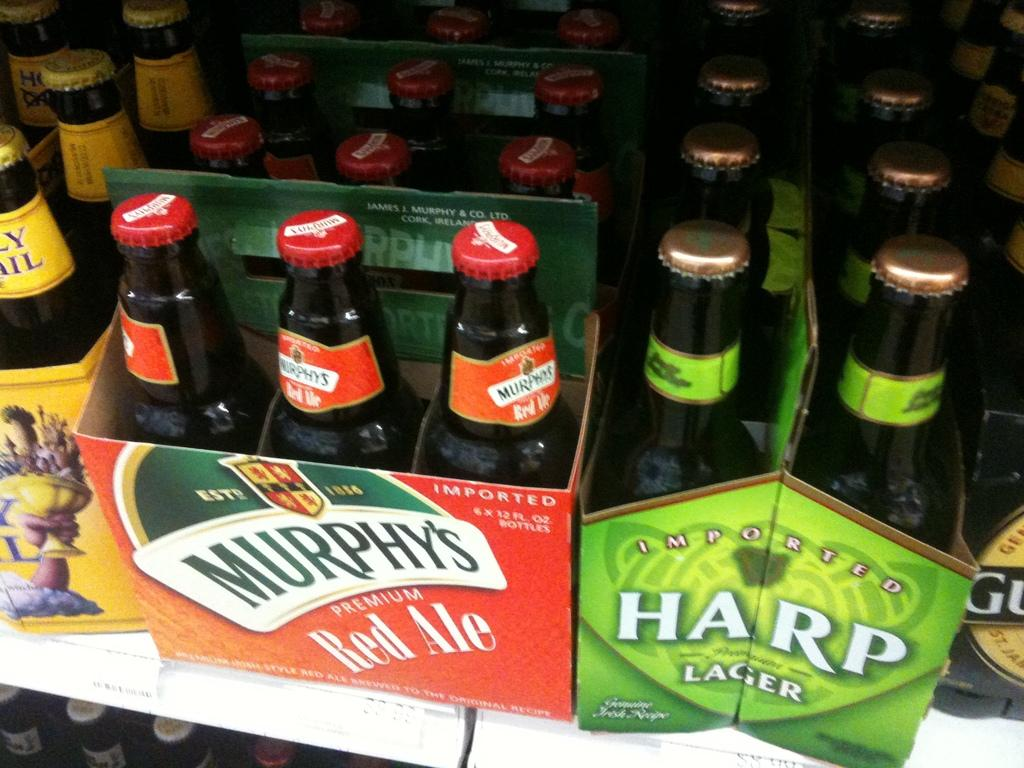<image>
Write a terse but informative summary of the picture. A six pack of Murphy's Red Ale sits next to a pack of Harp Lager. 